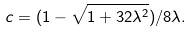<formula> <loc_0><loc_0><loc_500><loc_500>c = ( 1 - \sqrt { 1 + 3 2 \lambda ^ { 2 } } ) / 8 \lambda .</formula> 